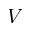Convert formula to latex. <formula><loc_0><loc_0><loc_500><loc_500>V</formula> 